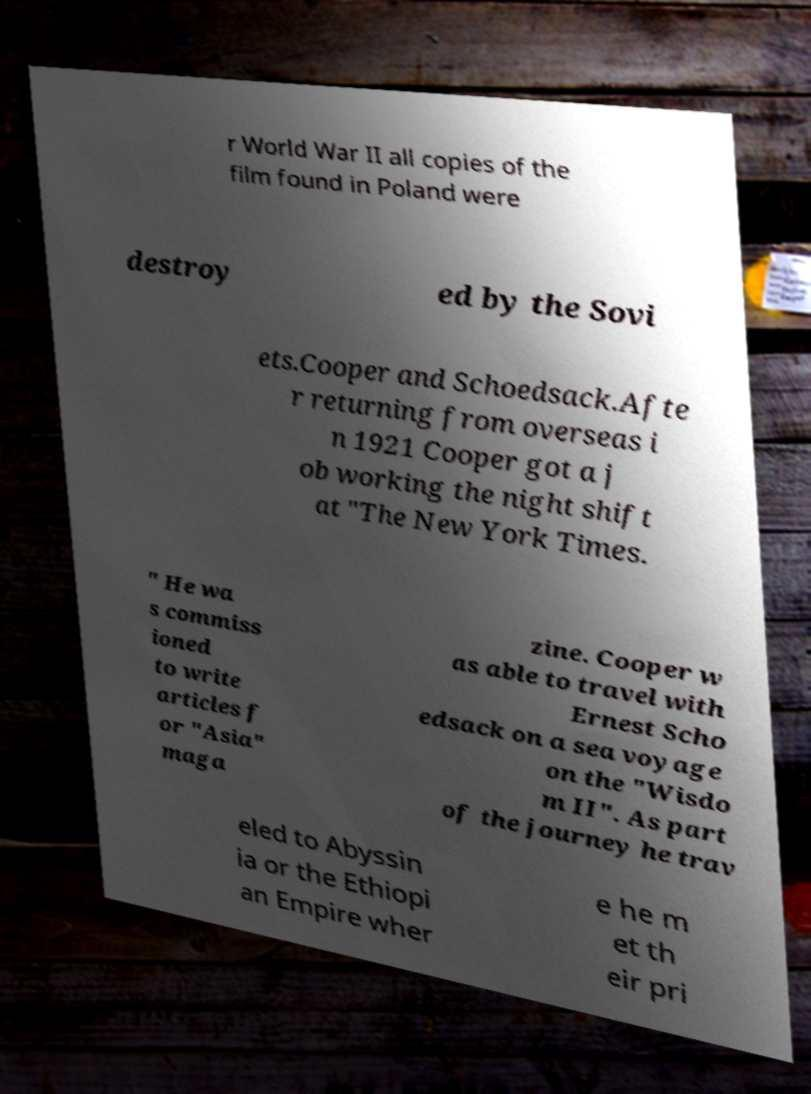For documentation purposes, I need the text within this image transcribed. Could you provide that? r World War II all copies of the film found in Poland were destroy ed by the Sovi ets.Cooper and Schoedsack.Afte r returning from overseas i n 1921 Cooper got a j ob working the night shift at "The New York Times. " He wa s commiss ioned to write articles f or "Asia" maga zine. Cooper w as able to travel with Ernest Scho edsack on a sea voyage on the "Wisdo m II". As part of the journey he trav eled to Abyssin ia or the Ethiopi an Empire wher e he m et th eir pri 